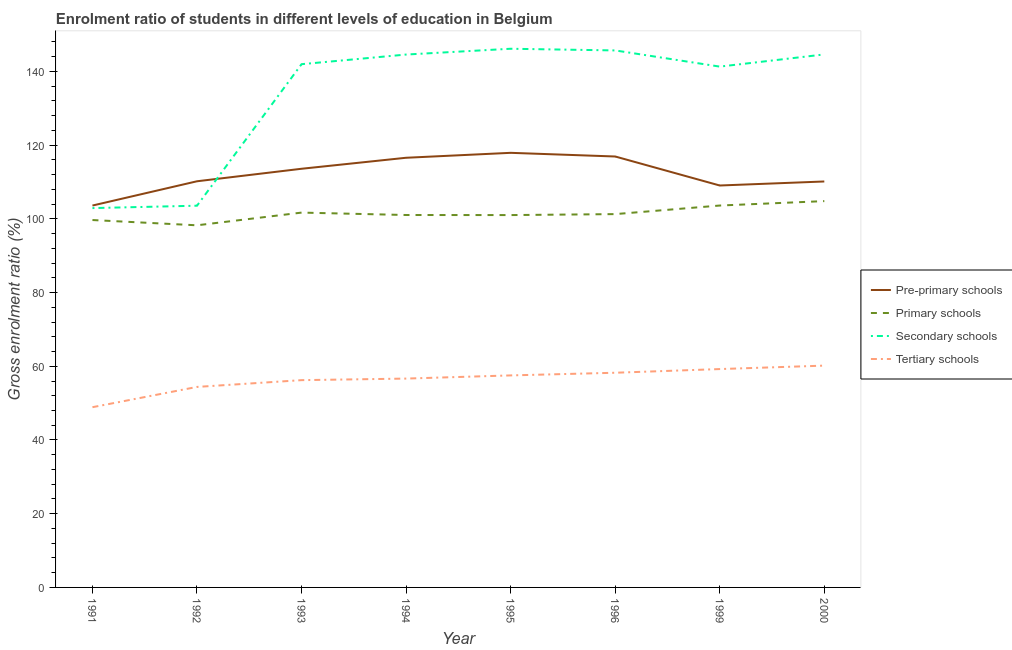How many different coloured lines are there?
Ensure brevity in your answer.  4. Does the line corresponding to gross enrolment ratio in pre-primary schools intersect with the line corresponding to gross enrolment ratio in primary schools?
Offer a terse response. No. What is the gross enrolment ratio in secondary schools in 1991?
Provide a short and direct response. 102.92. Across all years, what is the maximum gross enrolment ratio in pre-primary schools?
Offer a very short reply. 117.91. Across all years, what is the minimum gross enrolment ratio in primary schools?
Give a very brief answer. 98.25. In which year was the gross enrolment ratio in primary schools maximum?
Your response must be concise. 2000. In which year was the gross enrolment ratio in tertiary schools minimum?
Provide a short and direct response. 1991. What is the total gross enrolment ratio in primary schools in the graph?
Provide a succinct answer. 811.39. What is the difference between the gross enrolment ratio in pre-primary schools in 1992 and that in 1993?
Your answer should be very brief. -3.4. What is the difference between the gross enrolment ratio in secondary schools in 1991 and the gross enrolment ratio in primary schools in 1999?
Your response must be concise. -0.69. What is the average gross enrolment ratio in secondary schools per year?
Ensure brevity in your answer.  133.85. In the year 1993, what is the difference between the gross enrolment ratio in pre-primary schools and gross enrolment ratio in secondary schools?
Offer a very short reply. -28.37. In how many years, is the gross enrolment ratio in pre-primary schools greater than 64 %?
Keep it short and to the point. 8. What is the ratio of the gross enrolment ratio in pre-primary schools in 1995 to that in 2000?
Make the answer very short. 1.07. Is the gross enrolment ratio in pre-primary schools in 1993 less than that in 1999?
Make the answer very short. No. Is the difference between the gross enrolment ratio in primary schools in 1994 and 2000 greater than the difference between the gross enrolment ratio in tertiary schools in 1994 and 2000?
Keep it short and to the point. No. What is the difference between the highest and the second highest gross enrolment ratio in tertiary schools?
Make the answer very short. 0.93. What is the difference between the highest and the lowest gross enrolment ratio in secondary schools?
Offer a terse response. 43.23. Is the sum of the gross enrolment ratio in primary schools in 1993 and 1994 greater than the maximum gross enrolment ratio in tertiary schools across all years?
Keep it short and to the point. Yes. Is it the case that in every year, the sum of the gross enrolment ratio in primary schools and gross enrolment ratio in pre-primary schools is greater than the sum of gross enrolment ratio in secondary schools and gross enrolment ratio in tertiary schools?
Offer a terse response. Yes. Does the gross enrolment ratio in secondary schools monotonically increase over the years?
Offer a terse response. No. What is the difference between two consecutive major ticks on the Y-axis?
Make the answer very short. 20. Are the values on the major ticks of Y-axis written in scientific E-notation?
Make the answer very short. No. Does the graph contain grids?
Offer a terse response. No. How are the legend labels stacked?
Your response must be concise. Vertical. What is the title of the graph?
Give a very brief answer. Enrolment ratio of students in different levels of education in Belgium. What is the label or title of the X-axis?
Ensure brevity in your answer.  Year. What is the label or title of the Y-axis?
Give a very brief answer. Gross enrolment ratio (%). What is the Gross enrolment ratio (%) of Pre-primary schools in 1991?
Ensure brevity in your answer.  103.61. What is the Gross enrolment ratio (%) in Primary schools in 1991?
Offer a very short reply. 99.68. What is the Gross enrolment ratio (%) of Secondary schools in 1991?
Offer a very short reply. 102.92. What is the Gross enrolment ratio (%) of Tertiary schools in 1991?
Your answer should be compact. 48.9. What is the Gross enrolment ratio (%) in Pre-primary schools in 1992?
Give a very brief answer. 110.19. What is the Gross enrolment ratio (%) of Primary schools in 1992?
Your answer should be very brief. 98.25. What is the Gross enrolment ratio (%) of Secondary schools in 1992?
Offer a very short reply. 103.57. What is the Gross enrolment ratio (%) in Tertiary schools in 1992?
Your response must be concise. 54.4. What is the Gross enrolment ratio (%) of Pre-primary schools in 1993?
Your answer should be very brief. 113.59. What is the Gross enrolment ratio (%) in Primary schools in 1993?
Make the answer very short. 101.7. What is the Gross enrolment ratio (%) of Secondary schools in 1993?
Your response must be concise. 141.96. What is the Gross enrolment ratio (%) of Tertiary schools in 1993?
Offer a very short reply. 56.24. What is the Gross enrolment ratio (%) in Pre-primary schools in 1994?
Offer a terse response. 116.57. What is the Gross enrolment ratio (%) of Primary schools in 1994?
Ensure brevity in your answer.  101.04. What is the Gross enrolment ratio (%) in Secondary schools in 1994?
Provide a succinct answer. 144.58. What is the Gross enrolment ratio (%) of Tertiary schools in 1994?
Ensure brevity in your answer.  56.66. What is the Gross enrolment ratio (%) of Pre-primary schools in 1995?
Give a very brief answer. 117.91. What is the Gross enrolment ratio (%) of Primary schools in 1995?
Make the answer very short. 101.02. What is the Gross enrolment ratio (%) in Secondary schools in 1995?
Make the answer very short. 146.15. What is the Gross enrolment ratio (%) in Tertiary schools in 1995?
Give a very brief answer. 57.52. What is the Gross enrolment ratio (%) of Pre-primary schools in 1996?
Offer a terse response. 116.92. What is the Gross enrolment ratio (%) in Primary schools in 1996?
Offer a very short reply. 101.29. What is the Gross enrolment ratio (%) of Secondary schools in 1996?
Offer a terse response. 145.69. What is the Gross enrolment ratio (%) of Tertiary schools in 1996?
Provide a short and direct response. 58.25. What is the Gross enrolment ratio (%) of Pre-primary schools in 1999?
Ensure brevity in your answer.  109.05. What is the Gross enrolment ratio (%) in Primary schools in 1999?
Make the answer very short. 103.61. What is the Gross enrolment ratio (%) of Secondary schools in 1999?
Your answer should be very brief. 141.3. What is the Gross enrolment ratio (%) of Tertiary schools in 1999?
Offer a terse response. 59.24. What is the Gross enrolment ratio (%) in Pre-primary schools in 2000?
Your response must be concise. 110.14. What is the Gross enrolment ratio (%) of Primary schools in 2000?
Keep it short and to the point. 104.81. What is the Gross enrolment ratio (%) of Secondary schools in 2000?
Your answer should be compact. 144.61. What is the Gross enrolment ratio (%) in Tertiary schools in 2000?
Provide a short and direct response. 60.18. Across all years, what is the maximum Gross enrolment ratio (%) of Pre-primary schools?
Provide a succinct answer. 117.91. Across all years, what is the maximum Gross enrolment ratio (%) of Primary schools?
Your response must be concise. 104.81. Across all years, what is the maximum Gross enrolment ratio (%) of Secondary schools?
Ensure brevity in your answer.  146.15. Across all years, what is the maximum Gross enrolment ratio (%) in Tertiary schools?
Ensure brevity in your answer.  60.18. Across all years, what is the minimum Gross enrolment ratio (%) of Pre-primary schools?
Provide a succinct answer. 103.61. Across all years, what is the minimum Gross enrolment ratio (%) in Primary schools?
Your answer should be compact. 98.25. Across all years, what is the minimum Gross enrolment ratio (%) of Secondary schools?
Offer a terse response. 102.92. Across all years, what is the minimum Gross enrolment ratio (%) in Tertiary schools?
Provide a short and direct response. 48.9. What is the total Gross enrolment ratio (%) in Pre-primary schools in the graph?
Give a very brief answer. 897.97. What is the total Gross enrolment ratio (%) in Primary schools in the graph?
Keep it short and to the point. 811.39. What is the total Gross enrolment ratio (%) in Secondary schools in the graph?
Give a very brief answer. 1070.78. What is the total Gross enrolment ratio (%) of Tertiary schools in the graph?
Provide a succinct answer. 451.39. What is the difference between the Gross enrolment ratio (%) of Pre-primary schools in 1991 and that in 1992?
Your response must be concise. -6.58. What is the difference between the Gross enrolment ratio (%) of Primary schools in 1991 and that in 1992?
Make the answer very short. 1.43. What is the difference between the Gross enrolment ratio (%) of Secondary schools in 1991 and that in 1992?
Give a very brief answer. -0.65. What is the difference between the Gross enrolment ratio (%) of Tertiary schools in 1991 and that in 1992?
Keep it short and to the point. -5.5. What is the difference between the Gross enrolment ratio (%) of Pre-primary schools in 1991 and that in 1993?
Your answer should be compact. -9.98. What is the difference between the Gross enrolment ratio (%) of Primary schools in 1991 and that in 1993?
Your answer should be very brief. -2.02. What is the difference between the Gross enrolment ratio (%) in Secondary schools in 1991 and that in 1993?
Your response must be concise. -39.04. What is the difference between the Gross enrolment ratio (%) in Tertiary schools in 1991 and that in 1993?
Your response must be concise. -7.34. What is the difference between the Gross enrolment ratio (%) in Pre-primary schools in 1991 and that in 1994?
Keep it short and to the point. -12.97. What is the difference between the Gross enrolment ratio (%) of Primary schools in 1991 and that in 1994?
Give a very brief answer. -1.36. What is the difference between the Gross enrolment ratio (%) in Secondary schools in 1991 and that in 1994?
Your response must be concise. -41.66. What is the difference between the Gross enrolment ratio (%) in Tertiary schools in 1991 and that in 1994?
Your answer should be compact. -7.77. What is the difference between the Gross enrolment ratio (%) of Pre-primary schools in 1991 and that in 1995?
Offer a terse response. -14.3. What is the difference between the Gross enrolment ratio (%) in Primary schools in 1991 and that in 1995?
Give a very brief answer. -1.35. What is the difference between the Gross enrolment ratio (%) in Secondary schools in 1991 and that in 1995?
Your answer should be compact. -43.23. What is the difference between the Gross enrolment ratio (%) in Tertiary schools in 1991 and that in 1995?
Provide a succinct answer. -8.63. What is the difference between the Gross enrolment ratio (%) in Pre-primary schools in 1991 and that in 1996?
Keep it short and to the point. -13.31. What is the difference between the Gross enrolment ratio (%) in Primary schools in 1991 and that in 1996?
Offer a terse response. -1.61. What is the difference between the Gross enrolment ratio (%) in Secondary schools in 1991 and that in 1996?
Offer a terse response. -42.77. What is the difference between the Gross enrolment ratio (%) of Tertiary schools in 1991 and that in 1996?
Your response must be concise. -9.35. What is the difference between the Gross enrolment ratio (%) in Pre-primary schools in 1991 and that in 1999?
Offer a very short reply. -5.44. What is the difference between the Gross enrolment ratio (%) in Primary schools in 1991 and that in 1999?
Your answer should be compact. -3.94. What is the difference between the Gross enrolment ratio (%) of Secondary schools in 1991 and that in 1999?
Provide a short and direct response. -38.38. What is the difference between the Gross enrolment ratio (%) of Tertiary schools in 1991 and that in 1999?
Offer a terse response. -10.35. What is the difference between the Gross enrolment ratio (%) of Pre-primary schools in 1991 and that in 2000?
Offer a very short reply. -6.53. What is the difference between the Gross enrolment ratio (%) in Primary schools in 1991 and that in 2000?
Keep it short and to the point. -5.14. What is the difference between the Gross enrolment ratio (%) in Secondary schools in 1991 and that in 2000?
Make the answer very short. -41.69. What is the difference between the Gross enrolment ratio (%) of Tertiary schools in 1991 and that in 2000?
Make the answer very short. -11.28. What is the difference between the Gross enrolment ratio (%) of Pre-primary schools in 1992 and that in 1993?
Provide a succinct answer. -3.4. What is the difference between the Gross enrolment ratio (%) of Primary schools in 1992 and that in 1993?
Keep it short and to the point. -3.45. What is the difference between the Gross enrolment ratio (%) of Secondary schools in 1992 and that in 1993?
Provide a succinct answer. -38.4. What is the difference between the Gross enrolment ratio (%) in Tertiary schools in 1992 and that in 1993?
Your answer should be very brief. -1.84. What is the difference between the Gross enrolment ratio (%) in Pre-primary schools in 1992 and that in 1994?
Offer a very short reply. -6.38. What is the difference between the Gross enrolment ratio (%) in Primary schools in 1992 and that in 1994?
Provide a short and direct response. -2.79. What is the difference between the Gross enrolment ratio (%) of Secondary schools in 1992 and that in 1994?
Offer a very short reply. -41.01. What is the difference between the Gross enrolment ratio (%) of Tertiary schools in 1992 and that in 1994?
Ensure brevity in your answer.  -2.26. What is the difference between the Gross enrolment ratio (%) in Pre-primary schools in 1992 and that in 1995?
Provide a short and direct response. -7.72. What is the difference between the Gross enrolment ratio (%) in Primary schools in 1992 and that in 1995?
Offer a terse response. -2.77. What is the difference between the Gross enrolment ratio (%) in Secondary schools in 1992 and that in 1995?
Provide a short and direct response. -42.58. What is the difference between the Gross enrolment ratio (%) in Tertiary schools in 1992 and that in 1995?
Make the answer very short. -3.12. What is the difference between the Gross enrolment ratio (%) of Pre-primary schools in 1992 and that in 1996?
Offer a terse response. -6.72. What is the difference between the Gross enrolment ratio (%) of Primary schools in 1992 and that in 1996?
Provide a succinct answer. -3.04. What is the difference between the Gross enrolment ratio (%) of Secondary schools in 1992 and that in 1996?
Give a very brief answer. -42.13. What is the difference between the Gross enrolment ratio (%) of Tertiary schools in 1992 and that in 1996?
Ensure brevity in your answer.  -3.85. What is the difference between the Gross enrolment ratio (%) of Pre-primary schools in 1992 and that in 1999?
Provide a succinct answer. 1.15. What is the difference between the Gross enrolment ratio (%) of Primary schools in 1992 and that in 1999?
Provide a short and direct response. -5.36. What is the difference between the Gross enrolment ratio (%) in Secondary schools in 1992 and that in 1999?
Your answer should be very brief. -37.74. What is the difference between the Gross enrolment ratio (%) in Tertiary schools in 1992 and that in 1999?
Provide a succinct answer. -4.85. What is the difference between the Gross enrolment ratio (%) in Pre-primary schools in 1992 and that in 2000?
Provide a succinct answer. 0.05. What is the difference between the Gross enrolment ratio (%) of Primary schools in 1992 and that in 2000?
Provide a short and direct response. -6.56. What is the difference between the Gross enrolment ratio (%) in Secondary schools in 1992 and that in 2000?
Your answer should be compact. -41.04. What is the difference between the Gross enrolment ratio (%) in Tertiary schools in 1992 and that in 2000?
Your response must be concise. -5.78. What is the difference between the Gross enrolment ratio (%) in Pre-primary schools in 1993 and that in 1994?
Your answer should be compact. -2.99. What is the difference between the Gross enrolment ratio (%) in Primary schools in 1993 and that in 1994?
Provide a succinct answer. 0.65. What is the difference between the Gross enrolment ratio (%) in Secondary schools in 1993 and that in 1994?
Your answer should be very brief. -2.62. What is the difference between the Gross enrolment ratio (%) of Tertiary schools in 1993 and that in 1994?
Give a very brief answer. -0.43. What is the difference between the Gross enrolment ratio (%) of Pre-primary schools in 1993 and that in 1995?
Offer a very short reply. -4.32. What is the difference between the Gross enrolment ratio (%) of Primary schools in 1993 and that in 1995?
Offer a very short reply. 0.67. What is the difference between the Gross enrolment ratio (%) in Secondary schools in 1993 and that in 1995?
Provide a succinct answer. -4.19. What is the difference between the Gross enrolment ratio (%) in Tertiary schools in 1993 and that in 1995?
Ensure brevity in your answer.  -1.29. What is the difference between the Gross enrolment ratio (%) of Pre-primary schools in 1993 and that in 1996?
Provide a succinct answer. -3.33. What is the difference between the Gross enrolment ratio (%) of Primary schools in 1993 and that in 1996?
Your answer should be compact. 0.41. What is the difference between the Gross enrolment ratio (%) of Secondary schools in 1993 and that in 1996?
Keep it short and to the point. -3.73. What is the difference between the Gross enrolment ratio (%) in Tertiary schools in 1993 and that in 1996?
Offer a terse response. -2.01. What is the difference between the Gross enrolment ratio (%) of Pre-primary schools in 1993 and that in 1999?
Your answer should be very brief. 4.54. What is the difference between the Gross enrolment ratio (%) in Primary schools in 1993 and that in 1999?
Ensure brevity in your answer.  -1.92. What is the difference between the Gross enrolment ratio (%) in Secondary schools in 1993 and that in 1999?
Provide a short and direct response. 0.66. What is the difference between the Gross enrolment ratio (%) in Tertiary schools in 1993 and that in 1999?
Your answer should be compact. -3.01. What is the difference between the Gross enrolment ratio (%) in Pre-primary schools in 1993 and that in 2000?
Ensure brevity in your answer.  3.45. What is the difference between the Gross enrolment ratio (%) in Primary schools in 1993 and that in 2000?
Make the answer very short. -3.12. What is the difference between the Gross enrolment ratio (%) in Secondary schools in 1993 and that in 2000?
Your answer should be compact. -2.65. What is the difference between the Gross enrolment ratio (%) of Tertiary schools in 1993 and that in 2000?
Give a very brief answer. -3.94. What is the difference between the Gross enrolment ratio (%) of Pre-primary schools in 1994 and that in 1995?
Give a very brief answer. -1.34. What is the difference between the Gross enrolment ratio (%) in Primary schools in 1994 and that in 1995?
Your response must be concise. 0.02. What is the difference between the Gross enrolment ratio (%) in Secondary schools in 1994 and that in 1995?
Make the answer very short. -1.57. What is the difference between the Gross enrolment ratio (%) in Tertiary schools in 1994 and that in 1995?
Your answer should be compact. -0.86. What is the difference between the Gross enrolment ratio (%) in Pre-primary schools in 1994 and that in 1996?
Give a very brief answer. -0.34. What is the difference between the Gross enrolment ratio (%) of Primary schools in 1994 and that in 1996?
Your answer should be very brief. -0.24. What is the difference between the Gross enrolment ratio (%) in Secondary schools in 1994 and that in 1996?
Make the answer very short. -1.11. What is the difference between the Gross enrolment ratio (%) in Tertiary schools in 1994 and that in 1996?
Offer a terse response. -1.58. What is the difference between the Gross enrolment ratio (%) in Pre-primary schools in 1994 and that in 1999?
Make the answer very short. 7.53. What is the difference between the Gross enrolment ratio (%) in Primary schools in 1994 and that in 1999?
Make the answer very short. -2.57. What is the difference between the Gross enrolment ratio (%) in Secondary schools in 1994 and that in 1999?
Offer a very short reply. 3.27. What is the difference between the Gross enrolment ratio (%) in Tertiary schools in 1994 and that in 1999?
Offer a terse response. -2.58. What is the difference between the Gross enrolment ratio (%) of Pre-primary schools in 1994 and that in 2000?
Your response must be concise. 6.43. What is the difference between the Gross enrolment ratio (%) in Primary schools in 1994 and that in 2000?
Ensure brevity in your answer.  -3.77. What is the difference between the Gross enrolment ratio (%) in Secondary schools in 1994 and that in 2000?
Offer a very short reply. -0.03. What is the difference between the Gross enrolment ratio (%) of Tertiary schools in 1994 and that in 2000?
Provide a succinct answer. -3.52. What is the difference between the Gross enrolment ratio (%) of Pre-primary schools in 1995 and that in 1996?
Your answer should be very brief. 0.99. What is the difference between the Gross enrolment ratio (%) of Primary schools in 1995 and that in 1996?
Give a very brief answer. -0.26. What is the difference between the Gross enrolment ratio (%) of Secondary schools in 1995 and that in 1996?
Offer a very short reply. 0.46. What is the difference between the Gross enrolment ratio (%) of Tertiary schools in 1995 and that in 1996?
Your response must be concise. -0.72. What is the difference between the Gross enrolment ratio (%) in Pre-primary schools in 1995 and that in 1999?
Provide a short and direct response. 8.87. What is the difference between the Gross enrolment ratio (%) in Primary schools in 1995 and that in 1999?
Offer a very short reply. -2.59. What is the difference between the Gross enrolment ratio (%) in Secondary schools in 1995 and that in 1999?
Your answer should be very brief. 4.85. What is the difference between the Gross enrolment ratio (%) of Tertiary schools in 1995 and that in 1999?
Give a very brief answer. -1.72. What is the difference between the Gross enrolment ratio (%) of Pre-primary schools in 1995 and that in 2000?
Your answer should be compact. 7.77. What is the difference between the Gross enrolment ratio (%) in Primary schools in 1995 and that in 2000?
Give a very brief answer. -3.79. What is the difference between the Gross enrolment ratio (%) of Secondary schools in 1995 and that in 2000?
Provide a short and direct response. 1.54. What is the difference between the Gross enrolment ratio (%) in Tertiary schools in 1995 and that in 2000?
Your response must be concise. -2.66. What is the difference between the Gross enrolment ratio (%) in Pre-primary schools in 1996 and that in 1999?
Offer a terse response. 7.87. What is the difference between the Gross enrolment ratio (%) in Primary schools in 1996 and that in 1999?
Make the answer very short. -2.33. What is the difference between the Gross enrolment ratio (%) in Secondary schools in 1996 and that in 1999?
Ensure brevity in your answer.  4.39. What is the difference between the Gross enrolment ratio (%) of Tertiary schools in 1996 and that in 1999?
Make the answer very short. -1. What is the difference between the Gross enrolment ratio (%) of Pre-primary schools in 1996 and that in 2000?
Make the answer very short. 6.78. What is the difference between the Gross enrolment ratio (%) in Primary schools in 1996 and that in 2000?
Offer a terse response. -3.53. What is the difference between the Gross enrolment ratio (%) in Secondary schools in 1996 and that in 2000?
Offer a very short reply. 1.08. What is the difference between the Gross enrolment ratio (%) in Tertiary schools in 1996 and that in 2000?
Your answer should be very brief. -1.93. What is the difference between the Gross enrolment ratio (%) in Pre-primary schools in 1999 and that in 2000?
Ensure brevity in your answer.  -1.09. What is the difference between the Gross enrolment ratio (%) in Primary schools in 1999 and that in 2000?
Make the answer very short. -1.2. What is the difference between the Gross enrolment ratio (%) in Secondary schools in 1999 and that in 2000?
Give a very brief answer. -3.3. What is the difference between the Gross enrolment ratio (%) in Tertiary schools in 1999 and that in 2000?
Provide a short and direct response. -0.93. What is the difference between the Gross enrolment ratio (%) in Pre-primary schools in 1991 and the Gross enrolment ratio (%) in Primary schools in 1992?
Your response must be concise. 5.36. What is the difference between the Gross enrolment ratio (%) of Pre-primary schools in 1991 and the Gross enrolment ratio (%) of Secondary schools in 1992?
Provide a short and direct response. 0.04. What is the difference between the Gross enrolment ratio (%) of Pre-primary schools in 1991 and the Gross enrolment ratio (%) of Tertiary schools in 1992?
Provide a succinct answer. 49.21. What is the difference between the Gross enrolment ratio (%) of Primary schools in 1991 and the Gross enrolment ratio (%) of Secondary schools in 1992?
Provide a short and direct response. -3.89. What is the difference between the Gross enrolment ratio (%) in Primary schools in 1991 and the Gross enrolment ratio (%) in Tertiary schools in 1992?
Your response must be concise. 45.28. What is the difference between the Gross enrolment ratio (%) of Secondary schools in 1991 and the Gross enrolment ratio (%) of Tertiary schools in 1992?
Provide a short and direct response. 48.52. What is the difference between the Gross enrolment ratio (%) in Pre-primary schools in 1991 and the Gross enrolment ratio (%) in Primary schools in 1993?
Provide a succinct answer. 1.91. What is the difference between the Gross enrolment ratio (%) in Pre-primary schools in 1991 and the Gross enrolment ratio (%) in Secondary schools in 1993?
Provide a short and direct response. -38.35. What is the difference between the Gross enrolment ratio (%) of Pre-primary schools in 1991 and the Gross enrolment ratio (%) of Tertiary schools in 1993?
Provide a short and direct response. 47.37. What is the difference between the Gross enrolment ratio (%) in Primary schools in 1991 and the Gross enrolment ratio (%) in Secondary schools in 1993?
Your answer should be very brief. -42.29. What is the difference between the Gross enrolment ratio (%) of Primary schools in 1991 and the Gross enrolment ratio (%) of Tertiary schools in 1993?
Your answer should be compact. 43.44. What is the difference between the Gross enrolment ratio (%) of Secondary schools in 1991 and the Gross enrolment ratio (%) of Tertiary schools in 1993?
Offer a terse response. 46.68. What is the difference between the Gross enrolment ratio (%) of Pre-primary schools in 1991 and the Gross enrolment ratio (%) of Primary schools in 1994?
Offer a terse response. 2.57. What is the difference between the Gross enrolment ratio (%) in Pre-primary schools in 1991 and the Gross enrolment ratio (%) in Secondary schools in 1994?
Ensure brevity in your answer.  -40.97. What is the difference between the Gross enrolment ratio (%) of Pre-primary schools in 1991 and the Gross enrolment ratio (%) of Tertiary schools in 1994?
Ensure brevity in your answer.  46.94. What is the difference between the Gross enrolment ratio (%) of Primary schools in 1991 and the Gross enrolment ratio (%) of Secondary schools in 1994?
Make the answer very short. -44.9. What is the difference between the Gross enrolment ratio (%) in Primary schools in 1991 and the Gross enrolment ratio (%) in Tertiary schools in 1994?
Your answer should be very brief. 43.01. What is the difference between the Gross enrolment ratio (%) in Secondary schools in 1991 and the Gross enrolment ratio (%) in Tertiary schools in 1994?
Keep it short and to the point. 46.26. What is the difference between the Gross enrolment ratio (%) in Pre-primary schools in 1991 and the Gross enrolment ratio (%) in Primary schools in 1995?
Provide a short and direct response. 2.58. What is the difference between the Gross enrolment ratio (%) in Pre-primary schools in 1991 and the Gross enrolment ratio (%) in Secondary schools in 1995?
Keep it short and to the point. -42.54. What is the difference between the Gross enrolment ratio (%) of Pre-primary schools in 1991 and the Gross enrolment ratio (%) of Tertiary schools in 1995?
Make the answer very short. 46.08. What is the difference between the Gross enrolment ratio (%) in Primary schools in 1991 and the Gross enrolment ratio (%) in Secondary schools in 1995?
Give a very brief answer. -46.47. What is the difference between the Gross enrolment ratio (%) of Primary schools in 1991 and the Gross enrolment ratio (%) of Tertiary schools in 1995?
Your answer should be compact. 42.15. What is the difference between the Gross enrolment ratio (%) of Secondary schools in 1991 and the Gross enrolment ratio (%) of Tertiary schools in 1995?
Your answer should be compact. 45.4. What is the difference between the Gross enrolment ratio (%) of Pre-primary schools in 1991 and the Gross enrolment ratio (%) of Primary schools in 1996?
Offer a very short reply. 2.32. What is the difference between the Gross enrolment ratio (%) of Pre-primary schools in 1991 and the Gross enrolment ratio (%) of Secondary schools in 1996?
Give a very brief answer. -42.08. What is the difference between the Gross enrolment ratio (%) of Pre-primary schools in 1991 and the Gross enrolment ratio (%) of Tertiary schools in 1996?
Make the answer very short. 45.36. What is the difference between the Gross enrolment ratio (%) in Primary schools in 1991 and the Gross enrolment ratio (%) in Secondary schools in 1996?
Your answer should be compact. -46.02. What is the difference between the Gross enrolment ratio (%) in Primary schools in 1991 and the Gross enrolment ratio (%) in Tertiary schools in 1996?
Provide a succinct answer. 41.43. What is the difference between the Gross enrolment ratio (%) in Secondary schools in 1991 and the Gross enrolment ratio (%) in Tertiary schools in 1996?
Give a very brief answer. 44.67. What is the difference between the Gross enrolment ratio (%) of Pre-primary schools in 1991 and the Gross enrolment ratio (%) of Primary schools in 1999?
Offer a terse response. -0. What is the difference between the Gross enrolment ratio (%) of Pre-primary schools in 1991 and the Gross enrolment ratio (%) of Secondary schools in 1999?
Make the answer very short. -37.7. What is the difference between the Gross enrolment ratio (%) in Pre-primary schools in 1991 and the Gross enrolment ratio (%) in Tertiary schools in 1999?
Give a very brief answer. 44.36. What is the difference between the Gross enrolment ratio (%) in Primary schools in 1991 and the Gross enrolment ratio (%) in Secondary schools in 1999?
Provide a succinct answer. -41.63. What is the difference between the Gross enrolment ratio (%) of Primary schools in 1991 and the Gross enrolment ratio (%) of Tertiary schools in 1999?
Make the answer very short. 40.43. What is the difference between the Gross enrolment ratio (%) of Secondary schools in 1991 and the Gross enrolment ratio (%) of Tertiary schools in 1999?
Keep it short and to the point. 43.67. What is the difference between the Gross enrolment ratio (%) of Pre-primary schools in 1991 and the Gross enrolment ratio (%) of Primary schools in 2000?
Make the answer very short. -1.2. What is the difference between the Gross enrolment ratio (%) in Pre-primary schools in 1991 and the Gross enrolment ratio (%) in Secondary schools in 2000?
Your answer should be very brief. -41. What is the difference between the Gross enrolment ratio (%) of Pre-primary schools in 1991 and the Gross enrolment ratio (%) of Tertiary schools in 2000?
Offer a very short reply. 43.43. What is the difference between the Gross enrolment ratio (%) in Primary schools in 1991 and the Gross enrolment ratio (%) in Secondary schools in 2000?
Provide a succinct answer. -44.93. What is the difference between the Gross enrolment ratio (%) in Primary schools in 1991 and the Gross enrolment ratio (%) in Tertiary schools in 2000?
Offer a terse response. 39.5. What is the difference between the Gross enrolment ratio (%) in Secondary schools in 1991 and the Gross enrolment ratio (%) in Tertiary schools in 2000?
Keep it short and to the point. 42.74. What is the difference between the Gross enrolment ratio (%) of Pre-primary schools in 1992 and the Gross enrolment ratio (%) of Primary schools in 1993?
Ensure brevity in your answer.  8.5. What is the difference between the Gross enrolment ratio (%) of Pre-primary schools in 1992 and the Gross enrolment ratio (%) of Secondary schools in 1993?
Ensure brevity in your answer.  -31.77. What is the difference between the Gross enrolment ratio (%) in Pre-primary schools in 1992 and the Gross enrolment ratio (%) in Tertiary schools in 1993?
Provide a short and direct response. 53.95. What is the difference between the Gross enrolment ratio (%) of Primary schools in 1992 and the Gross enrolment ratio (%) of Secondary schools in 1993?
Your response must be concise. -43.71. What is the difference between the Gross enrolment ratio (%) of Primary schools in 1992 and the Gross enrolment ratio (%) of Tertiary schools in 1993?
Offer a very short reply. 42.01. What is the difference between the Gross enrolment ratio (%) of Secondary schools in 1992 and the Gross enrolment ratio (%) of Tertiary schools in 1993?
Make the answer very short. 47.33. What is the difference between the Gross enrolment ratio (%) in Pre-primary schools in 1992 and the Gross enrolment ratio (%) in Primary schools in 1994?
Your response must be concise. 9.15. What is the difference between the Gross enrolment ratio (%) of Pre-primary schools in 1992 and the Gross enrolment ratio (%) of Secondary schools in 1994?
Offer a very short reply. -34.39. What is the difference between the Gross enrolment ratio (%) in Pre-primary schools in 1992 and the Gross enrolment ratio (%) in Tertiary schools in 1994?
Provide a succinct answer. 53.53. What is the difference between the Gross enrolment ratio (%) in Primary schools in 1992 and the Gross enrolment ratio (%) in Secondary schools in 1994?
Your answer should be compact. -46.33. What is the difference between the Gross enrolment ratio (%) of Primary schools in 1992 and the Gross enrolment ratio (%) of Tertiary schools in 1994?
Your answer should be compact. 41.58. What is the difference between the Gross enrolment ratio (%) of Secondary schools in 1992 and the Gross enrolment ratio (%) of Tertiary schools in 1994?
Your answer should be compact. 46.9. What is the difference between the Gross enrolment ratio (%) of Pre-primary schools in 1992 and the Gross enrolment ratio (%) of Primary schools in 1995?
Make the answer very short. 9.17. What is the difference between the Gross enrolment ratio (%) of Pre-primary schools in 1992 and the Gross enrolment ratio (%) of Secondary schools in 1995?
Ensure brevity in your answer.  -35.96. What is the difference between the Gross enrolment ratio (%) of Pre-primary schools in 1992 and the Gross enrolment ratio (%) of Tertiary schools in 1995?
Offer a very short reply. 52.67. What is the difference between the Gross enrolment ratio (%) in Primary schools in 1992 and the Gross enrolment ratio (%) in Secondary schools in 1995?
Your answer should be very brief. -47.9. What is the difference between the Gross enrolment ratio (%) of Primary schools in 1992 and the Gross enrolment ratio (%) of Tertiary schools in 1995?
Make the answer very short. 40.72. What is the difference between the Gross enrolment ratio (%) of Secondary schools in 1992 and the Gross enrolment ratio (%) of Tertiary schools in 1995?
Provide a short and direct response. 46.04. What is the difference between the Gross enrolment ratio (%) of Pre-primary schools in 1992 and the Gross enrolment ratio (%) of Primary schools in 1996?
Give a very brief answer. 8.91. What is the difference between the Gross enrolment ratio (%) in Pre-primary schools in 1992 and the Gross enrolment ratio (%) in Secondary schools in 1996?
Give a very brief answer. -35.5. What is the difference between the Gross enrolment ratio (%) of Pre-primary schools in 1992 and the Gross enrolment ratio (%) of Tertiary schools in 1996?
Provide a succinct answer. 51.95. What is the difference between the Gross enrolment ratio (%) of Primary schools in 1992 and the Gross enrolment ratio (%) of Secondary schools in 1996?
Offer a very short reply. -47.44. What is the difference between the Gross enrolment ratio (%) of Primary schools in 1992 and the Gross enrolment ratio (%) of Tertiary schools in 1996?
Ensure brevity in your answer.  40. What is the difference between the Gross enrolment ratio (%) in Secondary schools in 1992 and the Gross enrolment ratio (%) in Tertiary schools in 1996?
Offer a very short reply. 45.32. What is the difference between the Gross enrolment ratio (%) of Pre-primary schools in 1992 and the Gross enrolment ratio (%) of Primary schools in 1999?
Offer a terse response. 6.58. What is the difference between the Gross enrolment ratio (%) in Pre-primary schools in 1992 and the Gross enrolment ratio (%) in Secondary schools in 1999?
Provide a succinct answer. -31.11. What is the difference between the Gross enrolment ratio (%) of Pre-primary schools in 1992 and the Gross enrolment ratio (%) of Tertiary schools in 1999?
Your response must be concise. 50.95. What is the difference between the Gross enrolment ratio (%) in Primary schools in 1992 and the Gross enrolment ratio (%) in Secondary schools in 1999?
Your answer should be compact. -43.06. What is the difference between the Gross enrolment ratio (%) in Primary schools in 1992 and the Gross enrolment ratio (%) in Tertiary schools in 1999?
Provide a succinct answer. 39. What is the difference between the Gross enrolment ratio (%) in Secondary schools in 1992 and the Gross enrolment ratio (%) in Tertiary schools in 1999?
Your answer should be very brief. 44.32. What is the difference between the Gross enrolment ratio (%) of Pre-primary schools in 1992 and the Gross enrolment ratio (%) of Primary schools in 2000?
Make the answer very short. 5.38. What is the difference between the Gross enrolment ratio (%) in Pre-primary schools in 1992 and the Gross enrolment ratio (%) in Secondary schools in 2000?
Keep it short and to the point. -34.42. What is the difference between the Gross enrolment ratio (%) of Pre-primary schools in 1992 and the Gross enrolment ratio (%) of Tertiary schools in 2000?
Keep it short and to the point. 50.01. What is the difference between the Gross enrolment ratio (%) in Primary schools in 1992 and the Gross enrolment ratio (%) in Secondary schools in 2000?
Keep it short and to the point. -46.36. What is the difference between the Gross enrolment ratio (%) of Primary schools in 1992 and the Gross enrolment ratio (%) of Tertiary schools in 2000?
Your answer should be very brief. 38.07. What is the difference between the Gross enrolment ratio (%) in Secondary schools in 1992 and the Gross enrolment ratio (%) in Tertiary schools in 2000?
Your answer should be very brief. 43.39. What is the difference between the Gross enrolment ratio (%) of Pre-primary schools in 1993 and the Gross enrolment ratio (%) of Primary schools in 1994?
Your answer should be compact. 12.55. What is the difference between the Gross enrolment ratio (%) of Pre-primary schools in 1993 and the Gross enrolment ratio (%) of Secondary schools in 1994?
Your answer should be compact. -30.99. What is the difference between the Gross enrolment ratio (%) in Pre-primary schools in 1993 and the Gross enrolment ratio (%) in Tertiary schools in 1994?
Ensure brevity in your answer.  56.92. What is the difference between the Gross enrolment ratio (%) in Primary schools in 1993 and the Gross enrolment ratio (%) in Secondary schools in 1994?
Provide a short and direct response. -42.88. What is the difference between the Gross enrolment ratio (%) in Primary schools in 1993 and the Gross enrolment ratio (%) in Tertiary schools in 1994?
Keep it short and to the point. 45.03. What is the difference between the Gross enrolment ratio (%) of Secondary schools in 1993 and the Gross enrolment ratio (%) of Tertiary schools in 1994?
Keep it short and to the point. 85.3. What is the difference between the Gross enrolment ratio (%) in Pre-primary schools in 1993 and the Gross enrolment ratio (%) in Primary schools in 1995?
Your answer should be very brief. 12.56. What is the difference between the Gross enrolment ratio (%) of Pre-primary schools in 1993 and the Gross enrolment ratio (%) of Secondary schools in 1995?
Your response must be concise. -32.56. What is the difference between the Gross enrolment ratio (%) of Pre-primary schools in 1993 and the Gross enrolment ratio (%) of Tertiary schools in 1995?
Ensure brevity in your answer.  56.06. What is the difference between the Gross enrolment ratio (%) of Primary schools in 1993 and the Gross enrolment ratio (%) of Secondary schools in 1995?
Make the answer very short. -44.45. What is the difference between the Gross enrolment ratio (%) in Primary schools in 1993 and the Gross enrolment ratio (%) in Tertiary schools in 1995?
Your answer should be compact. 44.17. What is the difference between the Gross enrolment ratio (%) of Secondary schools in 1993 and the Gross enrolment ratio (%) of Tertiary schools in 1995?
Offer a terse response. 84.44. What is the difference between the Gross enrolment ratio (%) of Pre-primary schools in 1993 and the Gross enrolment ratio (%) of Primary schools in 1996?
Your answer should be very brief. 12.3. What is the difference between the Gross enrolment ratio (%) in Pre-primary schools in 1993 and the Gross enrolment ratio (%) in Secondary schools in 1996?
Make the answer very short. -32.1. What is the difference between the Gross enrolment ratio (%) of Pre-primary schools in 1993 and the Gross enrolment ratio (%) of Tertiary schools in 1996?
Ensure brevity in your answer.  55.34. What is the difference between the Gross enrolment ratio (%) of Primary schools in 1993 and the Gross enrolment ratio (%) of Secondary schools in 1996?
Keep it short and to the point. -44. What is the difference between the Gross enrolment ratio (%) of Primary schools in 1993 and the Gross enrolment ratio (%) of Tertiary schools in 1996?
Make the answer very short. 43.45. What is the difference between the Gross enrolment ratio (%) in Secondary schools in 1993 and the Gross enrolment ratio (%) in Tertiary schools in 1996?
Offer a terse response. 83.72. What is the difference between the Gross enrolment ratio (%) of Pre-primary schools in 1993 and the Gross enrolment ratio (%) of Primary schools in 1999?
Make the answer very short. 9.98. What is the difference between the Gross enrolment ratio (%) in Pre-primary schools in 1993 and the Gross enrolment ratio (%) in Secondary schools in 1999?
Provide a short and direct response. -27.72. What is the difference between the Gross enrolment ratio (%) of Pre-primary schools in 1993 and the Gross enrolment ratio (%) of Tertiary schools in 1999?
Keep it short and to the point. 54.34. What is the difference between the Gross enrolment ratio (%) of Primary schools in 1993 and the Gross enrolment ratio (%) of Secondary schools in 1999?
Ensure brevity in your answer.  -39.61. What is the difference between the Gross enrolment ratio (%) of Primary schools in 1993 and the Gross enrolment ratio (%) of Tertiary schools in 1999?
Provide a succinct answer. 42.45. What is the difference between the Gross enrolment ratio (%) of Secondary schools in 1993 and the Gross enrolment ratio (%) of Tertiary schools in 1999?
Keep it short and to the point. 82.72. What is the difference between the Gross enrolment ratio (%) in Pre-primary schools in 1993 and the Gross enrolment ratio (%) in Primary schools in 2000?
Make the answer very short. 8.78. What is the difference between the Gross enrolment ratio (%) of Pre-primary schools in 1993 and the Gross enrolment ratio (%) of Secondary schools in 2000?
Offer a very short reply. -31.02. What is the difference between the Gross enrolment ratio (%) in Pre-primary schools in 1993 and the Gross enrolment ratio (%) in Tertiary schools in 2000?
Give a very brief answer. 53.41. What is the difference between the Gross enrolment ratio (%) in Primary schools in 1993 and the Gross enrolment ratio (%) in Secondary schools in 2000?
Ensure brevity in your answer.  -42.91. What is the difference between the Gross enrolment ratio (%) in Primary schools in 1993 and the Gross enrolment ratio (%) in Tertiary schools in 2000?
Your response must be concise. 41.52. What is the difference between the Gross enrolment ratio (%) in Secondary schools in 1993 and the Gross enrolment ratio (%) in Tertiary schools in 2000?
Provide a succinct answer. 81.78. What is the difference between the Gross enrolment ratio (%) of Pre-primary schools in 1994 and the Gross enrolment ratio (%) of Primary schools in 1995?
Offer a terse response. 15.55. What is the difference between the Gross enrolment ratio (%) of Pre-primary schools in 1994 and the Gross enrolment ratio (%) of Secondary schools in 1995?
Your answer should be very brief. -29.58. What is the difference between the Gross enrolment ratio (%) of Pre-primary schools in 1994 and the Gross enrolment ratio (%) of Tertiary schools in 1995?
Your answer should be very brief. 59.05. What is the difference between the Gross enrolment ratio (%) of Primary schools in 1994 and the Gross enrolment ratio (%) of Secondary schools in 1995?
Give a very brief answer. -45.11. What is the difference between the Gross enrolment ratio (%) of Primary schools in 1994 and the Gross enrolment ratio (%) of Tertiary schools in 1995?
Offer a very short reply. 43.52. What is the difference between the Gross enrolment ratio (%) in Secondary schools in 1994 and the Gross enrolment ratio (%) in Tertiary schools in 1995?
Provide a short and direct response. 87.05. What is the difference between the Gross enrolment ratio (%) of Pre-primary schools in 1994 and the Gross enrolment ratio (%) of Primary schools in 1996?
Your answer should be compact. 15.29. What is the difference between the Gross enrolment ratio (%) in Pre-primary schools in 1994 and the Gross enrolment ratio (%) in Secondary schools in 1996?
Your response must be concise. -29.12. What is the difference between the Gross enrolment ratio (%) of Pre-primary schools in 1994 and the Gross enrolment ratio (%) of Tertiary schools in 1996?
Provide a short and direct response. 58.33. What is the difference between the Gross enrolment ratio (%) in Primary schools in 1994 and the Gross enrolment ratio (%) in Secondary schools in 1996?
Keep it short and to the point. -44.65. What is the difference between the Gross enrolment ratio (%) in Primary schools in 1994 and the Gross enrolment ratio (%) in Tertiary schools in 1996?
Keep it short and to the point. 42.8. What is the difference between the Gross enrolment ratio (%) in Secondary schools in 1994 and the Gross enrolment ratio (%) in Tertiary schools in 1996?
Give a very brief answer. 86.33. What is the difference between the Gross enrolment ratio (%) in Pre-primary schools in 1994 and the Gross enrolment ratio (%) in Primary schools in 1999?
Offer a terse response. 12.96. What is the difference between the Gross enrolment ratio (%) of Pre-primary schools in 1994 and the Gross enrolment ratio (%) of Secondary schools in 1999?
Give a very brief answer. -24.73. What is the difference between the Gross enrolment ratio (%) of Pre-primary schools in 1994 and the Gross enrolment ratio (%) of Tertiary schools in 1999?
Keep it short and to the point. 57.33. What is the difference between the Gross enrolment ratio (%) of Primary schools in 1994 and the Gross enrolment ratio (%) of Secondary schools in 1999?
Make the answer very short. -40.26. What is the difference between the Gross enrolment ratio (%) in Primary schools in 1994 and the Gross enrolment ratio (%) in Tertiary schools in 1999?
Provide a succinct answer. 41.8. What is the difference between the Gross enrolment ratio (%) in Secondary schools in 1994 and the Gross enrolment ratio (%) in Tertiary schools in 1999?
Make the answer very short. 85.33. What is the difference between the Gross enrolment ratio (%) in Pre-primary schools in 1994 and the Gross enrolment ratio (%) in Primary schools in 2000?
Provide a succinct answer. 11.76. What is the difference between the Gross enrolment ratio (%) of Pre-primary schools in 1994 and the Gross enrolment ratio (%) of Secondary schools in 2000?
Keep it short and to the point. -28.04. What is the difference between the Gross enrolment ratio (%) of Pre-primary schools in 1994 and the Gross enrolment ratio (%) of Tertiary schools in 2000?
Ensure brevity in your answer.  56.39. What is the difference between the Gross enrolment ratio (%) of Primary schools in 1994 and the Gross enrolment ratio (%) of Secondary schools in 2000?
Provide a succinct answer. -43.57. What is the difference between the Gross enrolment ratio (%) in Primary schools in 1994 and the Gross enrolment ratio (%) in Tertiary schools in 2000?
Ensure brevity in your answer.  40.86. What is the difference between the Gross enrolment ratio (%) of Secondary schools in 1994 and the Gross enrolment ratio (%) of Tertiary schools in 2000?
Offer a very short reply. 84.4. What is the difference between the Gross enrolment ratio (%) of Pre-primary schools in 1995 and the Gross enrolment ratio (%) of Primary schools in 1996?
Provide a succinct answer. 16.63. What is the difference between the Gross enrolment ratio (%) in Pre-primary schools in 1995 and the Gross enrolment ratio (%) in Secondary schools in 1996?
Make the answer very short. -27.78. What is the difference between the Gross enrolment ratio (%) of Pre-primary schools in 1995 and the Gross enrolment ratio (%) of Tertiary schools in 1996?
Keep it short and to the point. 59.67. What is the difference between the Gross enrolment ratio (%) in Primary schools in 1995 and the Gross enrolment ratio (%) in Secondary schools in 1996?
Offer a very short reply. -44.67. What is the difference between the Gross enrolment ratio (%) in Primary schools in 1995 and the Gross enrolment ratio (%) in Tertiary schools in 1996?
Your answer should be very brief. 42.78. What is the difference between the Gross enrolment ratio (%) of Secondary schools in 1995 and the Gross enrolment ratio (%) of Tertiary schools in 1996?
Your answer should be very brief. 87.9. What is the difference between the Gross enrolment ratio (%) in Pre-primary schools in 1995 and the Gross enrolment ratio (%) in Primary schools in 1999?
Your answer should be compact. 14.3. What is the difference between the Gross enrolment ratio (%) in Pre-primary schools in 1995 and the Gross enrolment ratio (%) in Secondary schools in 1999?
Keep it short and to the point. -23.39. What is the difference between the Gross enrolment ratio (%) in Pre-primary schools in 1995 and the Gross enrolment ratio (%) in Tertiary schools in 1999?
Your answer should be compact. 58.67. What is the difference between the Gross enrolment ratio (%) in Primary schools in 1995 and the Gross enrolment ratio (%) in Secondary schools in 1999?
Ensure brevity in your answer.  -40.28. What is the difference between the Gross enrolment ratio (%) of Primary schools in 1995 and the Gross enrolment ratio (%) of Tertiary schools in 1999?
Your response must be concise. 41.78. What is the difference between the Gross enrolment ratio (%) in Secondary schools in 1995 and the Gross enrolment ratio (%) in Tertiary schools in 1999?
Make the answer very short. 86.9. What is the difference between the Gross enrolment ratio (%) of Pre-primary schools in 1995 and the Gross enrolment ratio (%) of Primary schools in 2000?
Your answer should be compact. 13.1. What is the difference between the Gross enrolment ratio (%) of Pre-primary schools in 1995 and the Gross enrolment ratio (%) of Secondary schools in 2000?
Provide a succinct answer. -26.7. What is the difference between the Gross enrolment ratio (%) in Pre-primary schools in 1995 and the Gross enrolment ratio (%) in Tertiary schools in 2000?
Offer a terse response. 57.73. What is the difference between the Gross enrolment ratio (%) in Primary schools in 1995 and the Gross enrolment ratio (%) in Secondary schools in 2000?
Offer a terse response. -43.59. What is the difference between the Gross enrolment ratio (%) of Primary schools in 1995 and the Gross enrolment ratio (%) of Tertiary schools in 2000?
Provide a short and direct response. 40.84. What is the difference between the Gross enrolment ratio (%) in Secondary schools in 1995 and the Gross enrolment ratio (%) in Tertiary schools in 2000?
Offer a terse response. 85.97. What is the difference between the Gross enrolment ratio (%) in Pre-primary schools in 1996 and the Gross enrolment ratio (%) in Primary schools in 1999?
Your answer should be very brief. 13.3. What is the difference between the Gross enrolment ratio (%) in Pre-primary schools in 1996 and the Gross enrolment ratio (%) in Secondary schools in 1999?
Offer a very short reply. -24.39. What is the difference between the Gross enrolment ratio (%) in Pre-primary schools in 1996 and the Gross enrolment ratio (%) in Tertiary schools in 1999?
Provide a short and direct response. 57.67. What is the difference between the Gross enrolment ratio (%) of Primary schools in 1996 and the Gross enrolment ratio (%) of Secondary schools in 1999?
Offer a very short reply. -40.02. What is the difference between the Gross enrolment ratio (%) of Primary schools in 1996 and the Gross enrolment ratio (%) of Tertiary schools in 1999?
Your answer should be very brief. 42.04. What is the difference between the Gross enrolment ratio (%) of Secondary schools in 1996 and the Gross enrolment ratio (%) of Tertiary schools in 1999?
Make the answer very short. 86.45. What is the difference between the Gross enrolment ratio (%) in Pre-primary schools in 1996 and the Gross enrolment ratio (%) in Primary schools in 2000?
Your answer should be very brief. 12.1. What is the difference between the Gross enrolment ratio (%) in Pre-primary schools in 1996 and the Gross enrolment ratio (%) in Secondary schools in 2000?
Provide a short and direct response. -27.69. What is the difference between the Gross enrolment ratio (%) in Pre-primary schools in 1996 and the Gross enrolment ratio (%) in Tertiary schools in 2000?
Keep it short and to the point. 56.74. What is the difference between the Gross enrolment ratio (%) of Primary schools in 1996 and the Gross enrolment ratio (%) of Secondary schools in 2000?
Offer a very short reply. -43.32. What is the difference between the Gross enrolment ratio (%) in Primary schools in 1996 and the Gross enrolment ratio (%) in Tertiary schools in 2000?
Provide a short and direct response. 41.11. What is the difference between the Gross enrolment ratio (%) of Secondary schools in 1996 and the Gross enrolment ratio (%) of Tertiary schools in 2000?
Make the answer very short. 85.51. What is the difference between the Gross enrolment ratio (%) of Pre-primary schools in 1999 and the Gross enrolment ratio (%) of Primary schools in 2000?
Your answer should be very brief. 4.23. What is the difference between the Gross enrolment ratio (%) in Pre-primary schools in 1999 and the Gross enrolment ratio (%) in Secondary schools in 2000?
Keep it short and to the point. -35.56. What is the difference between the Gross enrolment ratio (%) in Pre-primary schools in 1999 and the Gross enrolment ratio (%) in Tertiary schools in 2000?
Offer a very short reply. 48.87. What is the difference between the Gross enrolment ratio (%) of Primary schools in 1999 and the Gross enrolment ratio (%) of Secondary schools in 2000?
Offer a very short reply. -41. What is the difference between the Gross enrolment ratio (%) in Primary schools in 1999 and the Gross enrolment ratio (%) in Tertiary schools in 2000?
Make the answer very short. 43.43. What is the difference between the Gross enrolment ratio (%) of Secondary schools in 1999 and the Gross enrolment ratio (%) of Tertiary schools in 2000?
Your response must be concise. 81.12. What is the average Gross enrolment ratio (%) in Pre-primary schools per year?
Keep it short and to the point. 112.25. What is the average Gross enrolment ratio (%) of Primary schools per year?
Ensure brevity in your answer.  101.42. What is the average Gross enrolment ratio (%) in Secondary schools per year?
Make the answer very short. 133.85. What is the average Gross enrolment ratio (%) of Tertiary schools per year?
Offer a very short reply. 56.42. In the year 1991, what is the difference between the Gross enrolment ratio (%) in Pre-primary schools and Gross enrolment ratio (%) in Primary schools?
Give a very brief answer. 3.93. In the year 1991, what is the difference between the Gross enrolment ratio (%) in Pre-primary schools and Gross enrolment ratio (%) in Secondary schools?
Offer a very short reply. 0.69. In the year 1991, what is the difference between the Gross enrolment ratio (%) in Pre-primary schools and Gross enrolment ratio (%) in Tertiary schools?
Your answer should be compact. 54.71. In the year 1991, what is the difference between the Gross enrolment ratio (%) of Primary schools and Gross enrolment ratio (%) of Secondary schools?
Give a very brief answer. -3.24. In the year 1991, what is the difference between the Gross enrolment ratio (%) in Primary schools and Gross enrolment ratio (%) in Tertiary schools?
Provide a succinct answer. 50.78. In the year 1991, what is the difference between the Gross enrolment ratio (%) of Secondary schools and Gross enrolment ratio (%) of Tertiary schools?
Provide a succinct answer. 54.02. In the year 1992, what is the difference between the Gross enrolment ratio (%) of Pre-primary schools and Gross enrolment ratio (%) of Primary schools?
Ensure brevity in your answer.  11.94. In the year 1992, what is the difference between the Gross enrolment ratio (%) in Pre-primary schools and Gross enrolment ratio (%) in Secondary schools?
Provide a succinct answer. 6.63. In the year 1992, what is the difference between the Gross enrolment ratio (%) of Pre-primary schools and Gross enrolment ratio (%) of Tertiary schools?
Offer a very short reply. 55.79. In the year 1992, what is the difference between the Gross enrolment ratio (%) of Primary schools and Gross enrolment ratio (%) of Secondary schools?
Your answer should be compact. -5.32. In the year 1992, what is the difference between the Gross enrolment ratio (%) in Primary schools and Gross enrolment ratio (%) in Tertiary schools?
Provide a short and direct response. 43.85. In the year 1992, what is the difference between the Gross enrolment ratio (%) of Secondary schools and Gross enrolment ratio (%) of Tertiary schools?
Keep it short and to the point. 49.17. In the year 1993, what is the difference between the Gross enrolment ratio (%) of Pre-primary schools and Gross enrolment ratio (%) of Primary schools?
Provide a short and direct response. 11.89. In the year 1993, what is the difference between the Gross enrolment ratio (%) of Pre-primary schools and Gross enrolment ratio (%) of Secondary schools?
Keep it short and to the point. -28.37. In the year 1993, what is the difference between the Gross enrolment ratio (%) of Pre-primary schools and Gross enrolment ratio (%) of Tertiary schools?
Offer a very short reply. 57.35. In the year 1993, what is the difference between the Gross enrolment ratio (%) in Primary schools and Gross enrolment ratio (%) in Secondary schools?
Offer a very short reply. -40.27. In the year 1993, what is the difference between the Gross enrolment ratio (%) of Primary schools and Gross enrolment ratio (%) of Tertiary schools?
Your answer should be very brief. 45.46. In the year 1993, what is the difference between the Gross enrolment ratio (%) of Secondary schools and Gross enrolment ratio (%) of Tertiary schools?
Your response must be concise. 85.73. In the year 1994, what is the difference between the Gross enrolment ratio (%) in Pre-primary schools and Gross enrolment ratio (%) in Primary schools?
Your response must be concise. 15.53. In the year 1994, what is the difference between the Gross enrolment ratio (%) in Pre-primary schools and Gross enrolment ratio (%) in Secondary schools?
Keep it short and to the point. -28. In the year 1994, what is the difference between the Gross enrolment ratio (%) in Pre-primary schools and Gross enrolment ratio (%) in Tertiary schools?
Your answer should be compact. 59.91. In the year 1994, what is the difference between the Gross enrolment ratio (%) in Primary schools and Gross enrolment ratio (%) in Secondary schools?
Offer a terse response. -43.54. In the year 1994, what is the difference between the Gross enrolment ratio (%) of Primary schools and Gross enrolment ratio (%) of Tertiary schools?
Keep it short and to the point. 44.38. In the year 1994, what is the difference between the Gross enrolment ratio (%) of Secondary schools and Gross enrolment ratio (%) of Tertiary schools?
Keep it short and to the point. 87.91. In the year 1995, what is the difference between the Gross enrolment ratio (%) in Pre-primary schools and Gross enrolment ratio (%) in Primary schools?
Make the answer very short. 16.89. In the year 1995, what is the difference between the Gross enrolment ratio (%) in Pre-primary schools and Gross enrolment ratio (%) in Secondary schools?
Provide a short and direct response. -28.24. In the year 1995, what is the difference between the Gross enrolment ratio (%) of Pre-primary schools and Gross enrolment ratio (%) of Tertiary schools?
Your answer should be compact. 60.39. In the year 1995, what is the difference between the Gross enrolment ratio (%) in Primary schools and Gross enrolment ratio (%) in Secondary schools?
Make the answer very short. -45.13. In the year 1995, what is the difference between the Gross enrolment ratio (%) in Primary schools and Gross enrolment ratio (%) in Tertiary schools?
Your answer should be very brief. 43.5. In the year 1995, what is the difference between the Gross enrolment ratio (%) of Secondary schools and Gross enrolment ratio (%) of Tertiary schools?
Your answer should be compact. 88.63. In the year 1996, what is the difference between the Gross enrolment ratio (%) of Pre-primary schools and Gross enrolment ratio (%) of Primary schools?
Ensure brevity in your answer.  15.63. In the year 1996, what is the difference between the Gross enrolment ratio (%) of Pre-primary schools and Gross enrolment ratio (%) of Secondary schools?
Provide a short and direct response. -28.77. In the year 1996, what is the difference between the Gross enrolment ratio (%) in Pre-primary schools and Gross enrolment ratio (%) in Tertiary schools?
Your answer should be very brief. 58.67. In the year 1996, what is the difference between the Gross enrolment ratio (%) of Primary schools and Gross enrolment ratio (%) of Secondary schools?
Your answer should be very brief. -44.41. In the year 1996, what is the difference between the Gross enrolment ratio (%) in Primary schools and Gross enrolment ratio (%) in Tertiary schools?
Offer a terse response. 43.04. In the year 1996, what is the difference between the Gross enrolment ratio (%) in Secondary schools and Gross enrolment ratio (%) in Tertiary schools?
Offer a terse response. 87.45. In the year 1999, what is the difference between the Gross enrolment ratio (%) in Pre-primary schools and Gross enrolment ratio (%) in Primary schools?
Your answer should be compact. 5.43. In the year 1999, what is the difference between the Gross enrolment ratio (%) in Pre-primary schools and Gross enrolment ratio (%) in Secondary schools?
Your answer should be compact. -32.26. In the year 1999, what is the difference between the Gross enrolment ratio (%) in Pre-primary schools and Gross enrolment ratio (%) in Tertiary schools?
Offer a very short reply. 49.8. In the year 1999, what is the difference between the Gross enrolment ratio (%) in Primary schools and Gross enrolment ratio (%) in Secondary schools?
Offer a terse response. -37.69. In the year 1999, what is the difference between the Gross enrolment ratio (%) of Primary schools and Gross enrolment ratio (%) of Tertiary schools?
Offer a very short reply. 44.37. In the year 1999, what is the difference between the Gross enrolment ratio (%) in Secondary schools and Gross enrolment ratio (%) in Tertiary schools?
Your answer should be very brief. 82.06. In the year 2000, what is the difference between the Gross enrolment ratio (%) in Pre-primary schools and Gross enrolment ratio (%) in Primary schools?
Keep it short and to the point. 5.33. In the year 2000, what is the difference between the Gross enrolment ratio (%) of Pre-primary schools and Gross enrolment ratio (%) of Secondary schools?
Offer a terse response. -34.47. In the year 2000, what is the difference between the Gross enrolment ratio (%) of Pre-primary schools and Gross enrolment ratio (%) of Tertiary schools?
Offer a terse response. 49.96. In the year 2000, what is the difference between the Gross enrolment ratio (%) of Primary schools and Gross enrolment ratio (%) of Secondary schools?
Ensure brevity in your answer.  -39.8. In the year 2000, what is the difference between the Gross enrolment ratio (%) of Primary schools and Gross enrolment ratio (%) of Tertiary schools?
Provide a short and direct response. 44.63. In the year 2000, what is the difference between the Gross enrolment ratio (%) of Secondary schools and Gross enrolment ratio (%) of Tertiary schools?
Your answer should be very brief. 84.43. What is the ratio of the Gross enrolment ratio (%) of Pre-primary schools in 1991 to that in 1992?
Provide a short and direct response. 0.94. What is the ratio of the Gross enrolment ratio (%) of Primary schools in 1991 to that in 1992?
Offer a very short reply. 1.01. What is the ratio of the Gross enrolment ratio (%) of Secondary schools in 1991 to that in 1992?
Offer a terse response. 0.99. What is the ratio of the Gross enrolment ratio (%) of Tertiary schools in 1991 to that in 1992?
Offer a terse response. 0.9. What is the ratio of the Gross enrolment ratio (%) in Pre-primary schools in 1991 to that in 1993?
Offer a very short reply. 0.91. What is the ratio of the Gross enrolment ratio (%) in Primary schools in 1991 to that in 1993?
Make the answer very short. 0.98. What is the ratio of the Gross enrolment ratio (%) in Secondary schools in 1991 to that in 1993?
Give a very brief answer. 0.72. What is the ratio of the Gross enrolment ratio (%) of Tertiary schools in 1991 to that in 1993?
Offer a very short reply. 0.87. What is the ratio of the Gross enrolment ratio (%) in Pre-primary schools in 1991 to that in 1994?
Offer a terse response. 0.89. What is the ratio of the Gross enrolment ratio (%) in Primary schools in 1991 to that in 1994?
Make the answer very short. 0.99. What is the ratio of the Gross enrolment ratio (%) of Secondary schools in 1991 to that in 1994?
Your answer should be very brief. 0.71. What is the ratio of the Gross enrolment ratio (%) of Tertiary schools in 1991 to that in 1994?
Offer a very short reply. 0.86. What is the ratio of the Gross enrolment ratio (%) in Pre-primary schools in 1991 to that in 1995?
Your answer should be compact. 0.88. What is the ratio of the Gross enrolment ratio (%) in Primary schools in 1991 to that in 1995?
Provide a succinct answer. 0.99. What is the ratio of the Gross enrolment ratio (%) of Secondary schools in 1991 to that in 1995?
Give a very brief answer. 0.7. What is the ratio of the Gross enrolment ratio (%) of Tertiary schools in 1991 to that in 1995?
Make the answer very short. 0.85. What is the ratio of the Gross enrolment ratio (%) in Pre-primary schools in 1991 to that in 1996?
Provide a short and direct response. 0.89. What is the ratio of the Gross enrolment ratio (%) of Primary schools in 1991 to that in 1996?
Offer a very short reply. 0.98. What is the ratio of the Gross enrolment ratio (%) in Secondary schools in 1991 to that in 1996?
Ensure brevity in your answer.  0.71. What is the ratio of the Gross enrolment ratio (%) of Tertiary schools in 1991 to that in 1996?
Make the answer very short. 0.84. What is the ratio of the Gross enrolment ratio (%) of Pre-primary schools in 1991 to that in 1999?
Give a very brief answer. 0.95. What is the ratio of the Gross enrolment ratio (%) of Primary schools in 1991 to that in 1999?
Provide a succinct answer. 0.96. What is the ratio of the Gross enrolment ratio (%) of Secondary schools in 1991 to that in 1999?
Provide a succinct answer. 0.73. What is the ratio of the Gross enrolment ratio (%) in Tertiary schools in 1991 to that in 1999?
Provide a short and direct response. 0.83. What is the ratio of the Gross enrolment ratio (%) in Pre-primary schools in 1991 to that in 2000?
Provide a short and direct response. 0.94. What is the ratio of the Gross enrolment ratio (%) of Primary schools in 1991 to that in 2000?
Your answer should be compact. 0.95. What is the ratio of the Gross enrolment ratio (%) of Secondary schools in 1991 to that in 2000?
Your answer should be very brief. 0.71. What is the ratio of the Gross enrolment ratio (%) in Tertiary schools in 1991 to that in 2000?
Ensure brevity in your answer.  0.81. What is the ratio of the Gross enrolment ratio (%) in Pre-primary schools in 1992 to that in 1993?
Ensure brevity in your answer.  0.97. What is the ratio of the Gross enrolment ratio (%) in Primary schools in 1992 to that in 1993?
Your response must be concise. 0.97. What is the ratio of the Gross enrolment ratio (%) in Secondary schools in 1992 to that in 1993?
Your response must be concise. 0.73. What is the ratio of the Gross enrolment ratio (%) in Tertiary schools in 1992 to that in 1993?
Provide a succinct answer. 0.97. What is the ratio of the Gross enrolment ratio (%) of Pre-primary schools in 1992 to that in 1994?
Keep it short and to the point. 0.95. What is the ratio of the Gross enrolment ratio (%) of Primary schools in 1992 to that in 1994?
Your answer should be compact. 0.97. What is the ratio of the Gross enrolment ratio (%) in Secondary schools in 1992 to that in 1994?
Make the answer very short. 0.72. What is the ratio of the Gross enrolment ratio (%) in Tertiary schools in 1992 to that in 1994?
Offer a terse response. 0.96. What is the ratio of the Gross enrolment ratio (%) of Pre-primary schools in 1992 to that in 1995?
Give a very brief answer. 0.93. What is the ratio of the Gross enrolment ratio (%) of Primary schools in 1992 to that in 1995?
Ensure brevity in your answer.  0.97. What is the ratio of the Gross enrolment ratio (%) of Secondary schools in 1992 to that in 1995?
Provide a short and direct response. 0.71. What is the ratio of the Gross enrolment ratio (%) of Tertiary schools in 1992 to that in 1995?
Provide a short and direct response. 0.95. What is the ratio of the Gross enrolment ratio (%) in Pre-primary schools in 1992 to that in 1996?
Your answer should be compact. 0.94. What is the ratio of the Gross enrolment ratio (%) of Secondary schools in 1992 to that in 1996?
Your response must be concise. 0.71. What is the ratio of the Gross enrolment ratio (%) in Tertiary schools in 1992 to that in 1996?
Your answer should be very brief. 0.93. What is the ratio of the Gross enrolment ratio (%) in Pre-primary schools in 1992 to that in 1999?
Give a very brief answer. 1.01. What is the ratio of the Gross enrolment ratio (%) in Primary schools in 1992 to that in 1999?
Make the answer very short. 0.95. What is the ratio of the Gross enrolment ratio (%) of Secondary schools in 1992 to that in 1999?
Keep it short and to the point. 0.73. What is the ratio of the Gross enrolment ratio (%) of Tertiary schools in 1992 to that in 1999?
Make the answer very short. 0.92. What is the ratio of the Gross enrolment ratio (%) of Pre-primary schools in 1992 to that in 2000?
Ensure brevity in your answer.  1. What is the ratio of the Gross enrolment ratio (%) in Primary schools in 1992 to that in 2000?
Ensure brevity in your answer.  0.94. What is the ratio of the Gross enrolment ratio (%) in Secondary schools in 1992 to that in 2000?
Your answer should be very brief. 0.72. What is the ratio of the Gross enrolment ratio (%) of Tertiary schools in 1992 to that in 2000?
Give a very brief answer. 0.9. What is the ratio of the Gross enrolment ratio (%) in Pre-primary schools in 1993 to that in 1994?
Provide a short and direct response. 0.97. What is the ratio of the Gross enrolment ratio (%) in Primary schools in 1993 to that in 1994?
Offer a terse response. 1.01. What is the ratio of the Gross enrolment ratio (%) in Secondary schools in 1993 to that in 1994?
Provide a short and direct response. 0.98. What is the ratio of the Gross enrolment ratio (%) of Tertiary schools in 1993 to that in 1994?
Provide a succinct answer. 0.99. What is the ratio of the Gross enrolment ratio (%) in Pre-primary schools in 1993 to that in 1995?
Provide a succinct answer. 0.96. What is the ratio of the Gross enrolment ratio (%) of Primary schools in 1993 to that in 1995?
Your response must be concise. 1.01. What is the ratio of the Gross enrolment ratio (%) of Secondary schools in 1993 to that in 1995?
Offer a terse response. 0.97. What is the ratio of the Gross enrolment ratio (%) of Tertiary schools in 1993 to that in 1995?
Your answer should be very brief. 0.98. What is the ratio of the Gross enrolment ratio (%) in Pre-primary schools in 1993 to that in 1996?
Provide a short and direct response. 0.97. What is the ratio of the Gross enrolment ratio (%) of Primary schools in 1993 to that in 1996?
Provide a succinct answer. 1. What is the ratio of the Gross enrolment ratio (%) of Secondary schools in 1993 to that in 1996?
Make the answer very short. 0.97. What is the ratio of the Gross enrolment ratio (%) of Tertiary schools in 1993 to that in 1996?
Provide a succinct answer. 0.97. What is the ratio of the Gross enrolment ratio (%) in Pre-primary schools in 1993 to that in 1999?
Provide a short and direct response. 1.04. What is the ratio of the Gross enrolment ratio (%) of Primary schools in 1993 to that in 1999?
Provide a short and direct response. 0.98. What is the ratio of the Gross enrolment ratio (%) in Tertiary schools in 1993 to that in 1999?
Ensure brevity in your answer.  0.95. What is the ratio of the Gross enrolment ratio (%) in Pre-primary schools in 1993 to that in 2000?
Provide a short and direct response. 1.03. What is the ratio of the Gross enrolment ratio (%) of Primary schools in 1993 to that in 2000?
Your answer should be very brief. 0.97. What is the ratio of the Gross enrolment ratio (%) of Secondary schools in 1993 to that in 2000?
Give a very brief answer. 0.98. What is the ratio of the Gross enrolment ratio (%) of Tertiary schools in 1993 to that in 2000?
Provide a succinct answer. 0.93. What is the ratio of the Gross enrolment ratio (%) of Pre-primary schools in 1994 to that in 1995?
Make the answer very short. 0.99. What is the ratio of the Gross enrolment ratio (%) of Primary schools in 1994 to that in 1995?
Keep it short and to the point. 1. What is the ratio of the Gross enrolment ratio (%) in Tertiary schools in 1994 to that in 1995?
Offer a very short reply. 0.99. What is the ratio of the Gross enrolment ratio (%) in Secondary schools in 1994 to that in 1996?
Offer a very short reply. 0.99. What is the ratio of the Gross enrolment ratio (%) in Tertiary schools in 1994 to that in 1996?
Provide a succinct answer. 0.97. What is the ratio of the Gross enrolment ratio (%) of Pre-primary schools in 1994 to that in 1999?
Ensure brevity in your answer.  1.07. What is the ratio of the Gross enrolment ratio (%) in Primary schools in 1994 to that in 1999?
Your answer should be compact. 0.98. What is the ratio of the Gross enrolment ratio (%) of Secondary schools in 1994 to that in 1999?
Make the answer very short. 1.02. What is the ratio of the Gross enrolment ratio (%) of Tertiary schools in 1994 to that in 1999?
Your response must be concise. 0.96. What is the ratio of the Gross enrolment ratio (%) of Pre-primary schools in 1994 to that in 2000?
Provide a short and direct response. 1.06. What is the ratio of the Gross enrolment ratio (%) of Primary schools in 1994 to that in 2000?
Make the answer very short. 0.96. What is the ratio of the Gross enrolment ratio (%) of Tertiary schools in 1994 to that in 2000?
Make the answer very short. 0.94. What is the ratio of the Gross enrolment ratio (%) in Pre-primary schools in 1995 to that in 1996?
Make the answer very short. 1.01. What is the ratio of the Gross enrolment ratio (%) in Secondary schools in 1995 to that in 1996?
Make the answer very short. 1. What is the ratio of the Gross enrolment ratio (%) of Tertiary schools in 1995 to that in 1996?
Your answer should be very brief. 0.99. What is the ratio of the Gross enrolment ratio (%) in Pre-primary schools in 1995 to that in 1999?
Give a very brief answer. 1.08. What is the ratio of the Gross enrolment ratio (%) of Secondary schools in 1995 to that in 1999?
Offer a very short reply. 1.03. What is the ratio of the Gross enrolment ratio (%) in Tertiary schools in 1995 to that in 1999?
Give a very brief answer. 0.97. What is the ratio of the Gross enrolment ratio (%) in Pre-primary schools in 1995 to that in 2000?
Your response must be concise. 1.07. What is the ratio of the Gross enrolment ratio (%) of Primary schools in 1995 to that in 2000?
Ensure brevity in your answer.  0.96. What is the ratio of the Gross enrolment ratio (%) of Secondary schools in 1995 to that in 2000?
Your answer should be very brief. 1.01. What is the ratio of the Gross enrolment ratio (%) of Tertiary schools in 1995 to that in 2000?
Offer a terse response. 0.96. What is the ratio of the Gross enrolment ratio (%) in Pre-primary schools in 1996 to that in 1999?
Offer a very short reply. 1.07. What is the ratio of the Gross enrolment ratio (%) of Primary schools in 1996 to that in 1999?
Give a very brief answer. 0.98. What is the ratio of the Gross enrolment ratio (%) in Secondary schools in 1996 to that in 1999?
Your answer should be very brief. 1.03. What is the ratio of the Gross enrolment ratio (%) in Tertiary schools in 1996 to that in 1999?
Your response must be concise. 0.98. What is the ratio of the Gross enrolment ratio (%) in Pre-primary schools in 1996 to that in 2000?
Give a very brief answer. 1.06. What is the ratio of the Gross enrolment ratio (%) in Primary schools in 1996 to that in 2000?
Provide a short and direct response. 0.97. What is the ratio of the Gross enrolment ratio (%) in Secondary schools in 1996 to that in 2000?
Provide a short and direct response. 1.01. What is the ratio of the Gross enrolment ratio (%) of Tertiary schools in 1996 to that in 2000?
Your answer should be very brief. 0.97. What is the ratio of the Gross enrolment ratio (%) of Pre-primary schools in 1999 to that in 2000?
Provide a succinct answer. 0.99. What is the ratio of the Gross enrolment ratio (%) in Secondary schools in 1999 to that in 2000?
Your response must be concise. 0.98. What is the ratio of the Gross enrolment ratio (%) in Tertiary schools in 1999 to that in 2000?
Offer a terse response. 0.98. What is the difference between the highest and the second highest Gross enrolment ratio (%) of Primary schools?
Keep it short and to the point. 1.2. What is the difference between the highest and the second highest Gross enrolment ratio (%) of Secondary schools?
Keep it short and to the point. 0.46. What is the difference between the highest and the second highest Gross enrolment ratio (%) of Tertiary schools?
Ensure brevity in your answer.  0.93. What is the difference between the highest and the lowest Gross enrolment ratio (%) of Pre-primary schools?
Provide a succinct answer. 14.3. What is the difference between the highest and the lowest Gross enrolment ratio (%) of Primary schools?
Offer a very short reply. 6.56. What is the difference between the highest and the lowest Gross enrolment ratio (%) in Secondary schools?
Your answer should be compact. 43.23. What is the difference between the highest and the lowest Gross enrolment ratio (%) in Tertiary schools?
Offer a very short reply. 11.28. 